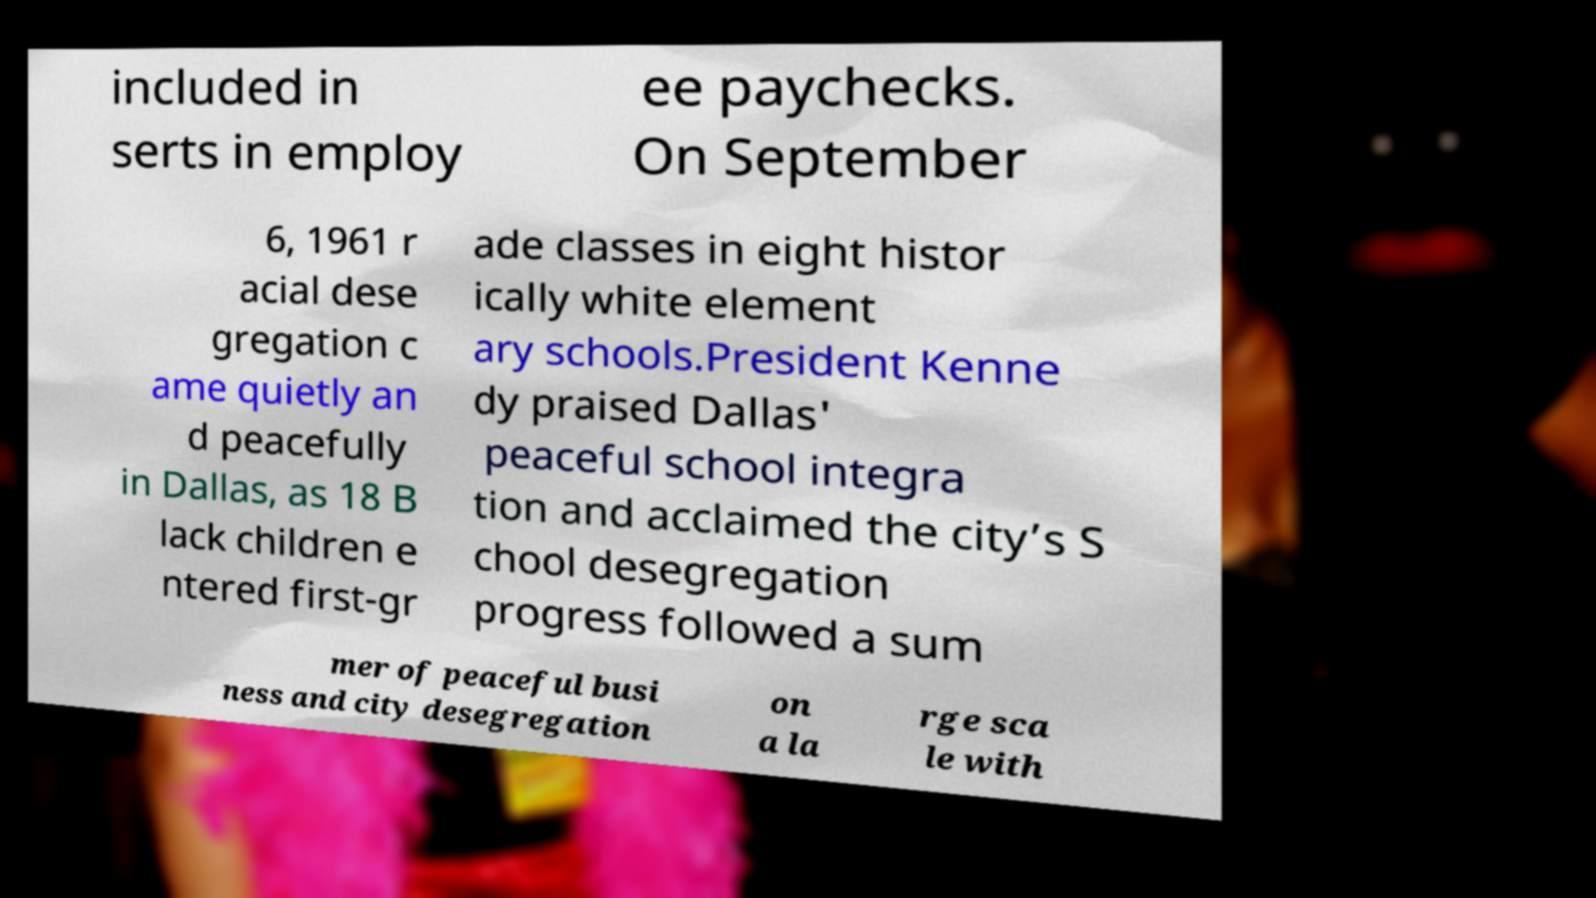Please read and relay the text visible in this image. What does it say? included in serts in employ ee paychecks. On September 6, 1961 r acial dese gregation c ame quietly an d peacefully in Dallas, as 18 B lack children e ntered first-gr ade classes in eight histor ically white element ary schools.President Kenne dy praised Dallas' peaceful school integra tion and acclaimed the city’s S chool desegregation progress followed a sum mer of peaceful busi ness and city desegregation on a la rge sca le with 